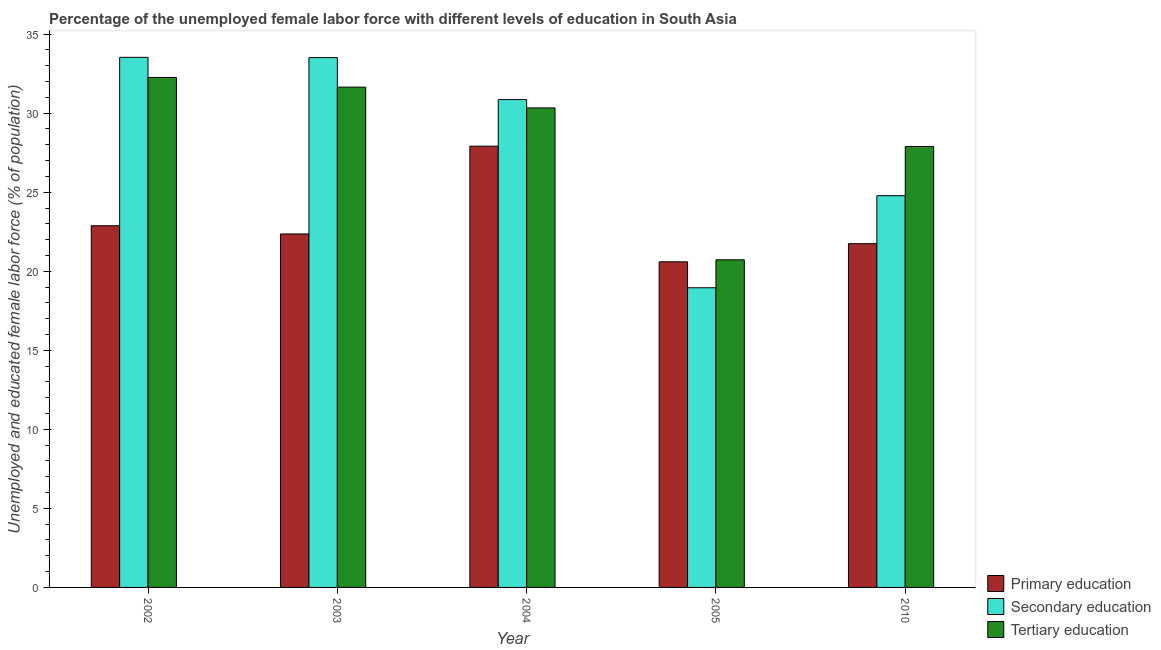How many groups of bars are there?
Keep it short and to the point. 5. Are the number of bars per tick equal to the number of legend labels?
Your answer should be compact. Yes. How many bars are there on the 5th tick from the left?
Provide a short and direct response. 3. How many bars are there on the 4th tick from the right?
Keep it short and to the point. 3. What is the percentage of female labor force who received tertiary education in 2010?
Give a very brief answer. 27.89. Across all years, what is the maximum percentage of female labor force who received primary education?
Provide a short and direct response. 27.91. Across all years, what is the minimum percentage of female labor force who received tertiary education?
Your answer should be compact. 20.72. In which year was the percentage of female labor force who received tertiary education minimum?
Offer a very short reply. 2005. What is the total percentage of female labor force who received secondary education in the graph?
Offer a terse response. 141.64. What is the difference between the percentage of female labor force who received tertiary education in 2005 and that in 2010?
Ensure brevity in your answer.  -7.17. What is the difference between the percentage of female labor force who received tertiary education in 2003 and the percentage of female labor force who received primary education in 2005?
Your answer should be very brief. 10.92. What is the average percentage of female labor force who received tertiary education per year?
Your answer should be compact. 28.57. In the year 2003, what is the difference between the percentage of female labor force who received secondary education and percentage of female labor force who received tertiary education?
Offer a very short reply. 0. In how many years, is the percentage of female labor force who received tertiary education greater than 17 %?
Keep it short and to the point. 5. What is the ratio of the percentage of female labor force who received tertiary education in 2004 to that in 2010?
Make the answer very short. 1.09. Is the percentage of female labor force who received primary education in 2003 less than that in 2010?
Keep it short and to the point. No. Is the difference between the percentage of female labor force who received secondary education in 2002 and 2005 greater than the difference between the percentage of female labor force who received tertiary education in 2002 and 2005?
Your answer should be very brief. No. What is the difference between the highest and the second highest percentage of female labor force who received secondary education?
Ensure brevity in your answer.  0.02. What is the difference between the highest and the lowest percentage of female labor force who received secondary education?
Your response must be concise. 14.58. In how many years, is the percentage of female labor force who received secondary education greater than the average percentage of female labor force who received secondary education taken over all years?
Make the answer very short. 3. What does the 3rd bar from the left in 2004 represents?
Provide a short and direct response. Tertiary education. How many bars are there?
Offer a very short reply. 15. Are the values on the major ticks of Y-axis written in scientific E-notation?
Offer a very short reply. No. Does the graph contain grids?
Make the answer very short. No. Where does the legend appear in the graph?
Offer a very short reply. Bottom right. How are the legend labels stacked?
Your response must be concise. Vertical. What is the title of the graph?
Make the answer very short. Percentage of the unemployed female labor force with different levels of education in South Asia. Does "Agriculture" appear as one of the legend labels in the graph?
Your response must be concise. No. What is the label or title of the Y-axis?
Give a very brief answer. Unemployed and educated female labor force (% of population). What is the Unemployed and educated female labor force (% of population) of Primary education in 2002?
Your response must be concise. 22.88. What is the Unemployed and educated female labor force (% of population) of Secondary education in 2002?
Offer a very short reply. 33.53. What is the Unemployed and educated female labor force (% of population) of Tertiary education in 2002?
Give a very brief answer. 32.26. What is the Unemployed and educated female labor force (% of population) in Primary education in 2003?
Make the answer very short. 22.36. What is the Unemployed and educated female labor force (% of population) in Secondary education in 2003?
Your answer should be very brief. 33.51. What is the Unemployed and educated female labor force (% of population) in Tertiary education in 2003?
Provide a succinct answer. 31.65. What is the Unemployed and educated female labor force (% of population) in Primary education in 2004?
Ensure brevity in your answer.  27.91. What is the Unemployed and educated female labor force (% of population) of Secondary education in 2004?
Your answer should be very brief. 30.86. What is the Unemployed and educated female labor force (% of population) of Tertiary education in 2004?
Your answer should be compact. 30.33. What is the Unemployed and educated female labor force (% of population) in Primary education in 2005?
Your response must be concise. 20.6. What is the Unemployed and educated female labor force (% of population) of Secondary education in 2005?
Offer a very short reply. 18.96. What is the Unemployed and educated female labor force (% of population) in Tertiary education in 2005?
Offer a very short reply. 20.72. What is the Unemployed and educated female labor force (% of population) of Primary education in 2010?
Provide a short and direct response. 21.74. What is the Unemployed and educated female labor force (% of population) of Secondary education in 2010?
Your answer should be very brief. 24.78. What is the Unemployed and educated female labor force (% of population) in Tertiary education in 2010?
Offer a very short reply. 27.89. Across all years, what is the maximum Unemployed and educated female labor force (% of population) in Primary education?
Your answer should be compact. 27.91. Across all years, what is the maximum Unemployed and educated female labor force (% of population) in Secondary education?
Your answer should be very brief. 33.53. Across all years, what is the maximum Unemployed and educated female labor force (% of population) in Tertiary education?
Provide a short and direct response. 32.26. Across all years, what is the minimum Unemployed and educated female labor force (% of population) in Primary education?
Your response must be concise. 20.6. Across all years, what is the minimum Unemployed and educated female labor force (% of population) in Secondary education?
Offer a terse response. 18.96. Across all years, what is the minimum Unemployed and educated female labor force (% of population) in Tertiary education?
Your answer should be very brief. 20.72. What is the total Unemployed and educated female labor force (% of population) in Primary education in the graph?
Your answer should be very brief. 115.49. What is the total Unemployed and educated female labor force (% of population) of Secondary education in the graph?
Offer a terse response. 141.64. What is the total Unemployed and educated female labor force (% of population) in Tertiary education in the graph?
Your response must be concise. 142.85. What is the difference between the Unemployed and educated female labor force (% of population) of Primary education in 2002 and that in 2003?
Keep it short and to the point. 0.52. What is the difference between the Unemployed and educated female labor force (% of population) in Secondary education in 2002 and that in 2003?
Provide a short and direct response. 0.02. What is the difference between the Unemployed and educated female labor force (% of population) in Tertiary education in 2002 and that in 2003?
Your answer should be compact. 0.61. What is the difference between the Unemployed and educated female labor force (% of population) of Primary education in 2002 and that in 2004?
Offer a terse response. -5.03. What is the difference between the Unemployed and educated female labor force (% of population) in Secondary education in 2002 and that in 2004?
Give a very brief answer. 2.67. What is the difference between the Unemployed and educated female labor force (% of population) of Tertiary education in 2002 and that in 2004?
Your answer should be compact. 1.93. What is the difference between the Unemployed and educated female labor force (% of population) of Primary education in 2002 and that in 2005?
Provide a short and direct response. 2.28. What is the difference between the Unemployed and educated female labor force (% of population) in Secondary education in 2002 and that in 2005?
Your answer should be very brief. 14.58. What is the difference between the Unemployed and educated female labor force (% of population) in Tertiary education in 2002 and that in 2005?
Your answer should be very brief. 11.53. What is the difference between the Unemployed and educated female labor force (% of population) of Primary education in 2002 and that in 2010?
Make the answer very short. 1.13. What is the difference between the Unemployed and educated female labor force (% of population) in Secondary education in 2002 and that in 2010?
Provide a succinct answer. 8.75. What is the difference between the Unemployed and educated female labor force (% of population) in Tertiary education in 2002 and that in 2010?
Give a very brief answer. 4.37. What is the difference between the Unemployed and educated female labor force (% of population) in Primary education in 2003 and that in 2004?
Offer a very short reply. -5.55. What is the difference between the Unemployed and educated female labor force (% of population) of Secondary education in 2003 and that in 2004?
Offer a terse response. 2.66. What is the difference between the Unemployed and educated female labor force (% of population) of Tertiary education in 2003 and that in 2004?
Provide a succinct answer. 1.31. What is the difference between the Unemployed and educated female labor force (% of population) in Primary education in 2003 and that in 2005?
Your answer should be compact. 1.76. What is the difference between the Unemployed and educated female labor force (% of population) in Secondary education in 2003 and that in 2005?
Provide a short and direct response. 14.56. What is the difference between the Unemployed and educated female labor force (% of population) in Tertiary education in 2003 and that in 2005?
Your response must be concise. 10.92. What is the difference between the Unemployed and educated female labor force (% of population) in Primary education in 2003 and that in 2010?
Offer a very short reply. 0.62. What is the difference between the Unemployed and educated female labor force (% of population) in Secondary education in 2003 and that in 2010?
Your response must be concise. 8.74. What is the difference between the Unemployed and educated female labor force (% of population) in Tertiary education in 2003 and that in 2010?
Keep it short and to the point. 3.75. What is the difference between the Unemployed and educated female labor force (% of population) in Primary education in 2004 and that in 2005?
Provide a succinct answer. 7.31. What is the difference between the Unemployed and educated female labor force (% of population) of Secondary education in 2004 and that in 2005?
Offer a terse response. 11.9. What is the difference between the Unemployed and educated female labor force (% of population) of Tertiary education in 2004 and that in 2005?
Offer a very short reply. 9.61. What is the difference between the Unemployed and educated female labor force (% of population) in Primary education in 2004 and that in 2010?
Your answer should be compact. 6.17. What is the difference between the Unemployed and educated female labor force (% of population) of Secondary education in 2004 and that in 2010?
Your answer should be compact. 6.08. What is the difference between the Unemployed and educated female labor force (% of population) in Tertiary education in 2004 and that in 2010?
Provide a short and direct response. 2.44. What is the difference between the Unemployed and educated female labor force (% of population) of Primary education in 2005 and that in 2010?
Provide a short and direct response. -1.15. What is the difference between the Unemployed and educated female labor force (% of population) of Secondary education in 2005 and that in 2010?
Make the answer very short. -5.82. What is the difference between the Unemployed and educated female labor force (% of population) in Tertiary education in 2005 and that in 2010?
Offer a terse response. -7.17. What is the difference between the Unemployed and educated female labor force (% of population) in Primary education in 2002 and the Unemployed and educated female labor force (% of population) in Secondary education in 2003?
Your answer should be very brief. -10.64. What is the difference between the Unemployed and educated female labor force (% of population) of Primary education in 2002 and the Unemployed and educated female labor force (% of population) of Tertiary education in 2003?
Provide a short and direct response. -8.77. What is the difference between the Unemployed and educated female labor force (% of population) in Secondary education in 2002 and the Unemployed and educated female labor force (% of population) in Tertiary education in 2003?
Provide a short and direct response. 1.89. What is the difference between the Unemployed and educated female labor force (% of population) in Primary education in 2002 and the Unemployed and educated female labor force (% of population) in Secondary education in 2004?
Make the answer very short. -7.98. What is the difference between the Unemployed and educated female labor force (% of population) of Primary education in 2002 and the Unemployed and educated female labor force (% of population) of Tertiary education in 2004?
Offer a very short reply. -7.45. What is the difference between the Unemployed and educated female labor force (% of population) of Secondary education in 2002 and the Unemployed and educated female labor force (% of population) of Tertiary education in 2004?
Give a very brief answer. 3.2. What is the difference between the Unemployed and educated female labor force (% of population) in Primary education in 2002 and the Unemployed and educated female labor force (% of population) in Secondary education in 2005?
Offer a terse response. 3.92. What is the difference between the Unemployed and educated female labor force (% of population) of Primary education in 2002 and the Unemployed and educated female labor force (% of population) of Tertiary education in 2005?
Keep it short and to the point. 2.15. What is the difference between the Unemployed and educated female labor force (% of population) in Secondary education in 2002 and the Unemployed and educated female labor force (% of population) in Tertiary education in 2005?
Ensure brevity in your answer.  12.81. What is the difference between the Unemployed and educated female labor force (% of population) in Primary education in 2002 and the Unemployed and educated female labor force (% of population) in Secondary education in 2010?
Offer a terse response. -1.9. What is the difference between the Unemployed and educated female labor force (% of population) of Primary education in 2002 and the Unemployed and educated female labor force (% of population) of Tertiary education in 2010?
Offer a very short reply. -5.01. What is the difference between the Unemployed and educated female labor force (% of population) of Secondary education in 2002 and the Unemployed and educated female labor force (% of population) of Tertiary education in 2010?
Give a very brief answer. 5.64. What is the difference between the Unemployed and educated female labor force (% of population) of Primary education in 2003 and the Unemployed and educated female labor force (% of population) of Secondary education in 2004?
Your answer should be very brief. -8.5. What is the difference between the Unemployed and educated female labor force (% of population) of Primary education in 2003 and the Unemployed and educated female labor force (% of population) of Tertiary education in 2004?
Your answer should be compact. -7.97. What is the difference between the Unemployed and educated female labor force (% of population) in Secondary education in 2003 and the Unemployed and educated female labor force (% of population) in Tertiary education in 2004?
Provide a short and direct response. 3.18. What is the difference between the Unemployed and educated female labor force (% of population) in Primary education in 2003 and the Unemployed and educated female labor force (% of population) in Secondary education in 2005?
Your answer should be compact. 3.4. What is the difference between the Unemployed and educated female labor force (% of population) of Primary education in 2003 and the Unemployed and educated female labor force (% of population) of Tertiary education in 2005?
Keep it short and to the point. 1.63. What is the difference between the Unemployed and educated female labor force (% of population) of Secondary education in 2003 and the Unemployed and educated female labor force (% of population) of Tertiary education in 2005?
Offer a terse response. 12.79. What is the difference between the Unemployed and educated female labor force (% of population) in Primary education in 2003 and the Unemployed and educated female labor force (% of population) in Secondary education in 2010?
Your answer should be compact. -2.42. What is the difference between the Unemployed and educated female labor force (% of population) of Primary education in 2003 and the Unemployed and educated female labor force (% of population) of Tertiary education in 2010?
Give a very brief answer. -5.53. What is the difference between the Unemployed and educated female labor force (% of population) in Secondary education in 2003 and the Unemployed and educated female labor force (% of population) in Tertiary education in 2010?
Your answer should be very brief. 5.62. What is the difference between the Unemployed and educated female labor force (% of population) in Primary education in 2004 and the Unemployed and educated female labor force (% of population) in Secondary education in 2005?
Offer a terse response. 8.95. What is the difference between the Unemployed and educated female labor force (% of population) of Primary education in 2004 and the Unemployed and educated female labor force (% of population) of Tertiary education in 2005?
Your response must be concise. 7.19. What is the difference between the Unemployed and educated female labor force (% of population) in Secondary education in 2004 and the Unemployed and educated female labor force (% of population) in Tertiary education in 2005?
Offer a terse response. 10.13. What is the difference between the Unemployed and educated female labor force (% of population) of Primary education in 2004 and the Unemployed and educated female labor force (% of population) of Secondary education in 2010?
Make the answer very short. 3.13. What is the difference between the Unemployed and educated female labor force (% of population) of Primary education in 2004 and the Unemployed and educated female labor force (% of population) of Tertiary education in 2010?
Give a very brief answer. 0.02. What is the difference between the Unemployed and educated female labor force (% of population) in Secondary education in 2004 and the Unemployed and educated female labor force (% of population) in Tertiary education in 2010?
Offer a very short reply. 2.96. What is the difference between the Unemployed and educated female labor force (% of population) in Primary education in 2005 and the Unemployed and educated female labor force (% of population) in Secondary education in 2010?
Provide a succinct answer. -4.18. What is the difference between the Unemployed and educated female labor force (% of population) in Primary education in 2005 and the Unemployed and educated female labor force (% of population) in Tertiary education in 2010?
Your answer should be compact. -7.3. What is the difference between the Unemployed and educated female labor force (% of population) in Secondary education in 2005 and the Unemployed and educated female labor force (% of population) in Tertiary education in 2010?
Give a very brief answer. -8.94. What is the average Unemployed and educated female labor force (% of population) in Primary education per year?
Your answer should be compact. 23.1. What is the average Unemployed and educated female labor force (% of population) of Secondary education per year?
Give a very brief answer. 28.33. What is the average Unemployed and educated female labor force (% of population) in Tertiary education per year?
Your answer should be compact. 28.57. In the year 2002, what is the difference between the Unemployed and educated female labor force (% of population) in Primary education and Unemployed and educated female labor force (% of population) in Secondary education?
Provide a succinct answer. -10.65. In the year 2002, what is the difference between the Unemployed and educated female labor force (% of population) in Primary education and Unemployed and educated female labor force (% of population) in Tertiary education?
Provide a succinct answer. -9.38. In the year 2002, what is the difference between the Unemployed and educated female labor force (% of population) of Secondary education and Unemployed and educated female labor force (% of population) of Tertiary education?
Provide a short and direct response. 1.27. In the year 2003, what is the difference between the Unemployed and educated female labor force (% of population) of Primary education and Unemployed and educated female labor force (% of population) of Secondary education?
Your answer should be very brief. -11.16. In the year 2003, what is the difference between the Unemployed and educated female labor force (% of population) of Primary education and Unemployed and educated female labor force (% of population) of Tertiary education?
Give a very brief answer. -9.29. In the year 2003, what is the difference between the Unemployed and educated female labor force (% of population) in Secondary education and Unemployed and educated female labor force (% of population) in Tertiary education?
Ensure brevity in your answer.  1.87. In the year 2004, what is the difference between the Unemployed and educated female labor force (% of population) in Primary education and Unemployed and educated female labor force (% of population) in Secondary education?
Your response must be concise. -2.95. In the year 2004, what is the difference between the Unemployed and educated female labor force (% of population) in Primary education and Unemployed and educated female labor force (% of population) in Tertiary education?
Provide a short and direct response. -2.42. In the year 2004, what is the difference between the Unemployed and educated female labor force (% of population) in Secondary education and Unemployed and educated female labor force (% of population) in Tertiary education?
Keep it short and to the point. 0.53. In the year 2005, what is the difference between the Unemployed and educated female labor force (% of population) in Primary education and Unemployed and educated female labor force (% of population) in Secondary education?
Make the answer very short. 1.64. In the year 2005, what is the difference between the Unemployed and educated female labor force (% of population) in Primary education and Unemployed and educated female labor force (% of population) in Tertiary education?
Provide a short and direct response. -0.13. In the year 2005, what is the difference between the Unemployed and educated female labor force (% of population) of Secondary education and Unemployed and educated female labor force (% of population) of Tertiary education?
Ensure brevity in your answer.  -1.77. In the year 2010, what is the difference between the Unemployed and educated female labor force (% of population) of Primary education and Unemployed and educated female labor force (% of population) of Secondary education?
Offer a very short reply. -3.03. In the year 2010, what is the difference between the Unemployed and educated female labor force (% of population) of Primary education and Unemployed and educated female labor force (% of population) of Tertiary education?
Provide a succinct answer. -6.15. In the year 2010, what is the difference between the Unemployed and educated female labor force (% of population) of Secondary education and Unemployed and educated female labor force (% of population) of Tertiary education?
Keep it short and to the point. -3.12. What is the ratio of the Unemployed and educated female labor force (% of population) in Primary education in 2002 to that in 2003?
Provide a short and direct response. 1.02. What is the ratio of the Unemployed and educated female labor force (% of population) in Secondary education in 2002 to that in 2003?
Your response must be concise. 1. What is the ratio of the Unemployed and educated female labor force (% of population) of Tertiary education in 2002 to that in 2003?
Give a very brief answer. 1.02. What is the ratio of the Unemployed and educated female labor force (% of population) of Primary education in 2002 to that in 2004?
Keep it short and to the point. 0.82. What is the ratio of the Unemployed and educated female labor force (% of population) in Secondary education in 2002 to that in 2004?
Your answer should be compact. 1.09. What is the ratio of the Unemployed and educated female labor force (% of population) of Tertiary education in 2002 to that in 2004?
Your response must be concise. 1.06. What is the ratio of the Unemployed and educated female labor force (% of population) in Primary education in 2002 to that in 2005?
Ensure brevity in your answer.  1.11. What is the ratio of the Unemployed and educated female labor force (% of population) in Secondary education in 2002 to that in 2005?
Your answer should be very brief. 1.77. What is the ratio of the Unemployed and educated female labor force (% of population) in Tertiary education in 2002 to that in 2005?
Offer a terse response. 1.56. What is the ratio of the Unemployed and educated female labor force (% of population) of Primary education in 2002 to that in 2010?
Offer a terse response. 1.05. What is the ratio of the Unemployed and educated female labor force (% of population) in Secondary education in 2002 to that in 2010?
Your response must be concise. 1.35. What is the ratio of the Unemployed and educated female labor force (% of population) of Tertiary education in 2002 to that in 2010?
Make the answer very short. 1.16. What is the ratio of the Unemployed and educated female labor force (% of population) in Primary education in 2003 to that in 2004?
Provide a short and direct response. 0.8. What is the ratio of the Unemployed and educated female labor force (% of population) in Secondary education in 2003 to that in 2004?
Keep it short and to the point. 1.09. What is the ratio of the Unemployed and educated female labor force (% of population) of Tertiary education in 2003 to that in 2004?
Provide a succinct answer. 1.04. What is the ratio of the Unemployed and educated female labor force (% of population) of Primary education in 2003 to that in 2005?
Your answer should be very brief. 1.09. What is the ratio of the Unemployed and educated female labor force (% of population) of Secondary education in 2003 to that in 2005?
Give a very brief answer. 1.77. What is the ratio of the Unemployed and educated female labor force (% of population) in Tertiary education in 2003 to that in 2005?
Your answer should be compact. 1.53. What is the ratio of the Unemployed and educated female labor force (% of population) in Primary education in 2003 to that in 2010?
Your response must be concise. 1.03. What is the ratio of the Unemployed and educated female labor force (% of population) in Secondary education in 2003 to that in 2010?
Keep it short and to the point. 1.35. What is the ratio of the Unemployed and educated female labor force (% of population) of Tertiary education in 2003 to that in 2010?
Offer a terse response. 1.13. What is the ratio of the Unemployed and educated female labor force (% of population) in Primary education in 2004 to that in 2005?
Your response must be concise. 1.36. What is the ratio of the Unemployed and educated female labor force (% of population) in Secondary education in 2004 to that in 2005?
Make the answer very short. 1.63. What is the ratio of the Unemployed and educated female labor force (% of population) in Tertiary education in 2004 to that in 2005?
Offer a terse response. 1.46. What is the ratio of the Unemployed and educated female labor force (% of population) of Primary education in 2004 to that in 2010?
Your answer should be very brief. 1.28. What is the ratio of the Unemployed and educated female labor force (% of population) of Secondary education in 2004 to that in 2010?
Provide a short and direct response. 1.25. What is the ratio of the Unemployed and educated female labor force (% of population) in Tertiary education in 2004 to that in 2010?
Make the answer very short. 1.09. What is the ratio of the Unemployed and educated female labor force (% of population) in Primary education in 2005 to that in 2010?
Your answer should be very brief. 0.95. What is the ratio of the Unemployed and educated female labor force (% of population) in Secondary education in 2005 to that in 2010?
Your answer should be compact. 0.77. What is the ratio of the Unemployed and educated female labor force (% of population) of Tertiary education in 2005 to that in 2010?
Keep it short and to the point. 0.74. What is the difference between the highest and the second highest Unemployed and educated female labor force (% of population) of Primary education?
Offer a terse response. 5.03. What is the difference between the highest and the second highest Unemployed and educated female labor force (% of population) of Secondary education?
Provide a succinct answer. 0.02. What is the difference between the highest and the second highest Unemployed and educated female labor force (% of population) of Tertiary education?
Ensure brevity in your answer.  0.61. What is the difference between the highest and the lowest Unemployed and educated female labor force (% of population) in Primary education?
Ensure brevity in your answer.  7.31. What is the difference between the highest and the lowest Unemployed and educated female labor force (% of population) in Secondary education?
Offer a terse response. 14.58. What is the difference between the highest and the lowest Unemployed and educated female labor force (% of population) in Tertiary education?
Make the answer very short. 11.53. 